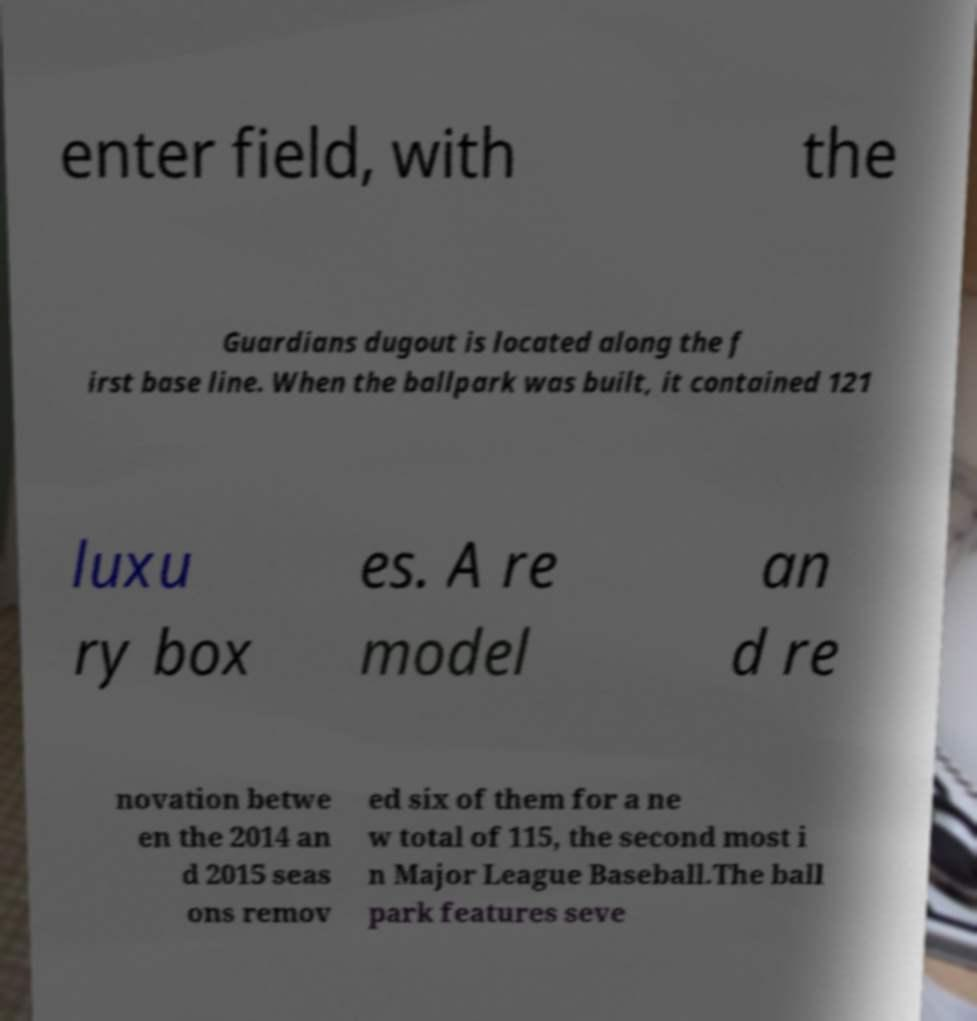I need the written content from this picture converted into text. Can you do that? enter field, with the Guardians dugout is located along the f irst base line. When the ballpark was built, it contained 121 luxu ry box es. A re model an d re novation betwe en the 2014 an d 2015 seas ons remov ed six of them for a ne w total of 115, the second most i n Major League Baseball.The ball park features seve 